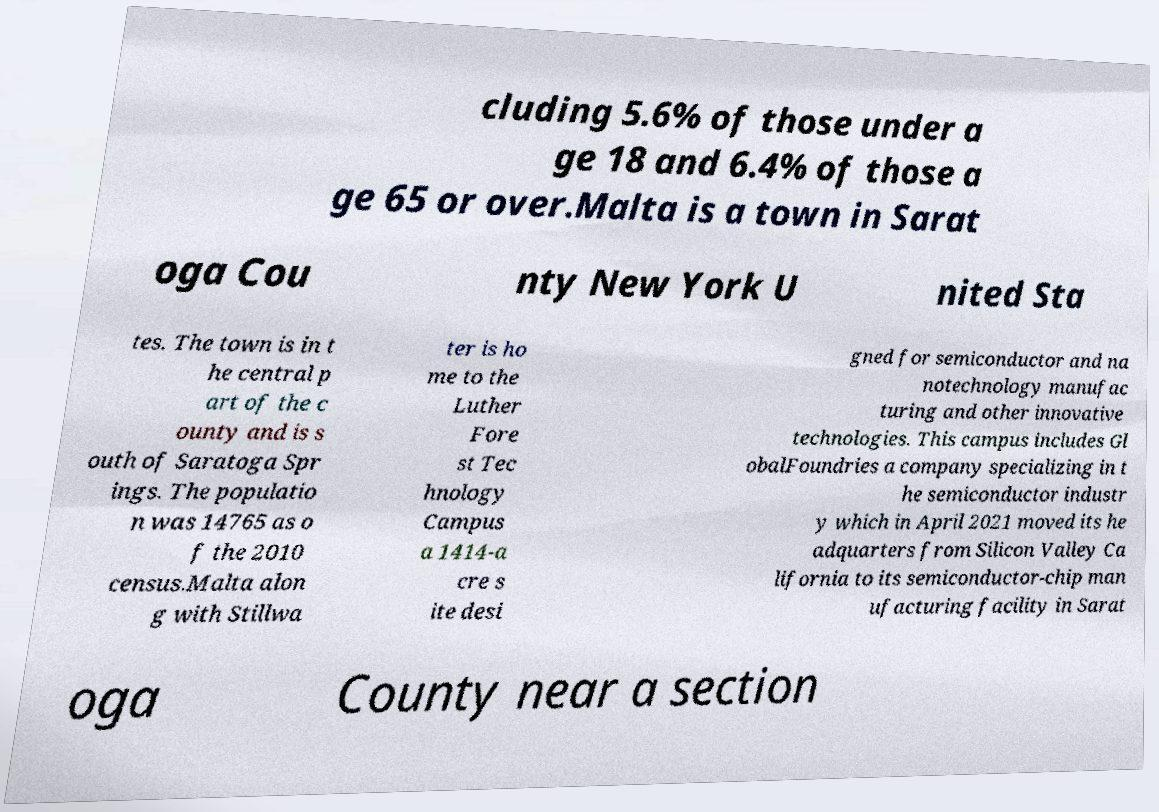Could you extract and type out the text from this image? cluding 5.6% of those under a ge 18 and 6.4% of those a ge 65 or over.Malta is a town in Sarat oga Cou nty New York U nited Sta tes. The town is in t he central p art of the c ounty and is s outh of Saratoga Spr ings. The populatio n was 14765 as o f the 2010 census.Malta alon g with Stillwa ter is ho me to the Luther Fore st Tec hnology Campus a 1414-a cre s ite desi gned for semiconductor and na notechnology manufac turing and other innovative technologies. This campus includes Gl obalFoundries a company specializing in t he semiconductor industr y which in April 2021 moved its he adquarters from Silicon Valley Ca lifornia to its semiconductor-chip man ufacturing facility in Sarat oga County near a section 